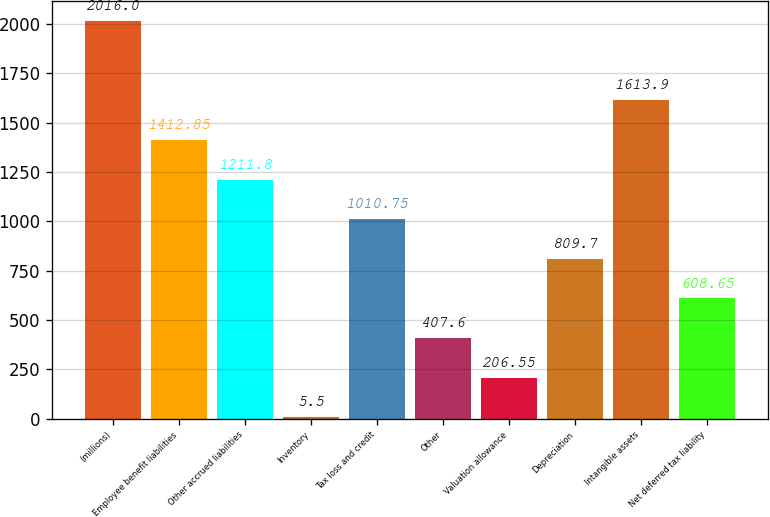<chart> <loc_0><loc_0><loc_500><loc_500><bar_chart><fcel>(millions)<fcel>Employee benefit liabilities<fcel>Other accrued liabilities<fcel>Inventory<fcel>Tax loss and credit<fcel>Other<fcel>Valuation allowance<fcel>Depreciation<fcel>Intangible assets<fcel>Net deferred tax liability<nl><fcel>2016<fcel>1412.85<fcel>1211.8<fcel>5.5<fcel>1010.75<fcel>407.6<fcel>206.55<fcel>809.7<fcel>1613.9<fcel>608.65<nl></chart> 